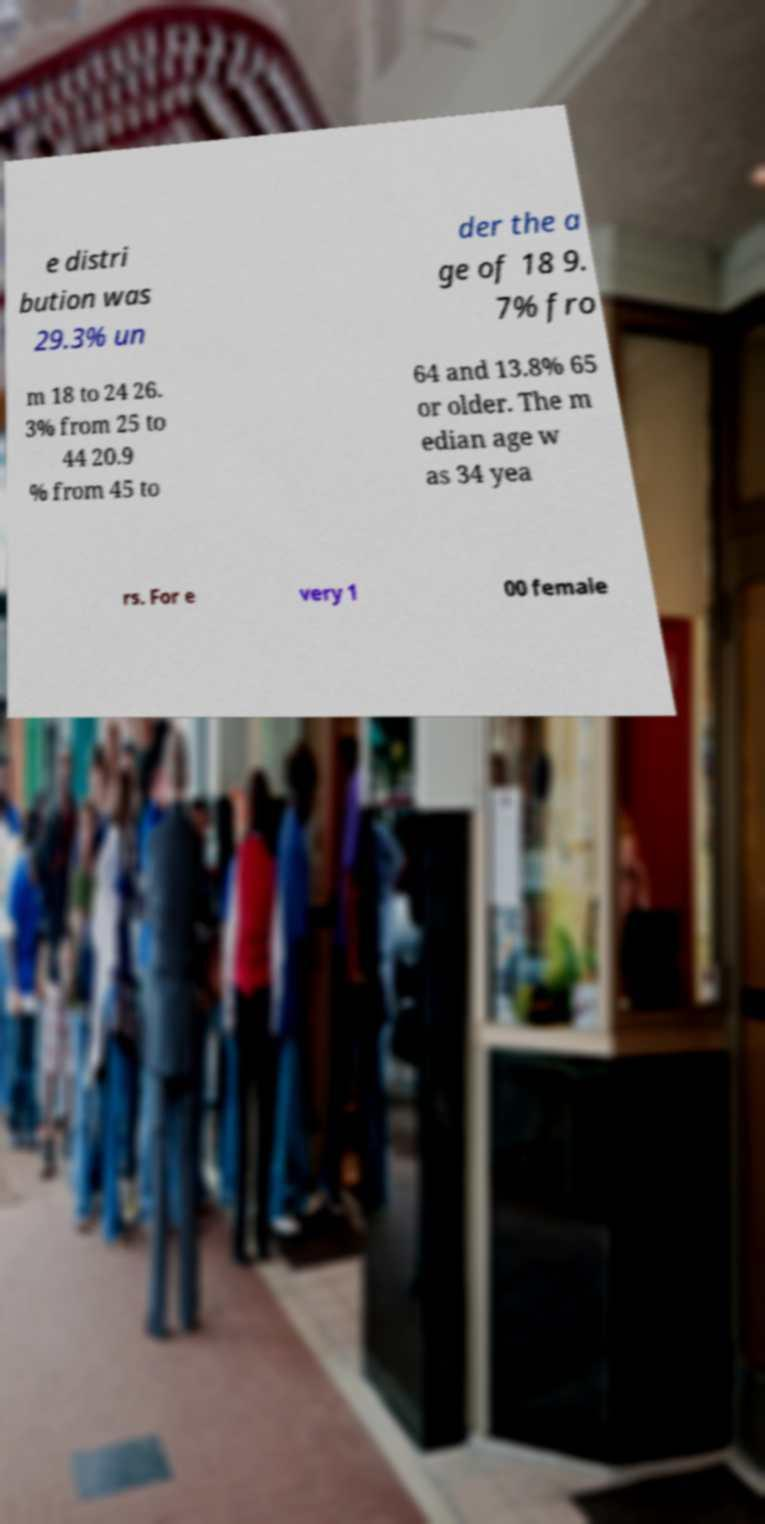What messages or text are displayed in this image? I need them in a readable, typed format. e distri bution was 29.3% un der the a ge of 18 9. 7% fro m 18 to 24 26. 3% from 25 to 44 20.9 % from 45 to 64 and 13.8% 65 or older. The m edian age w as 34 yea rs. For e very 1 00 female 